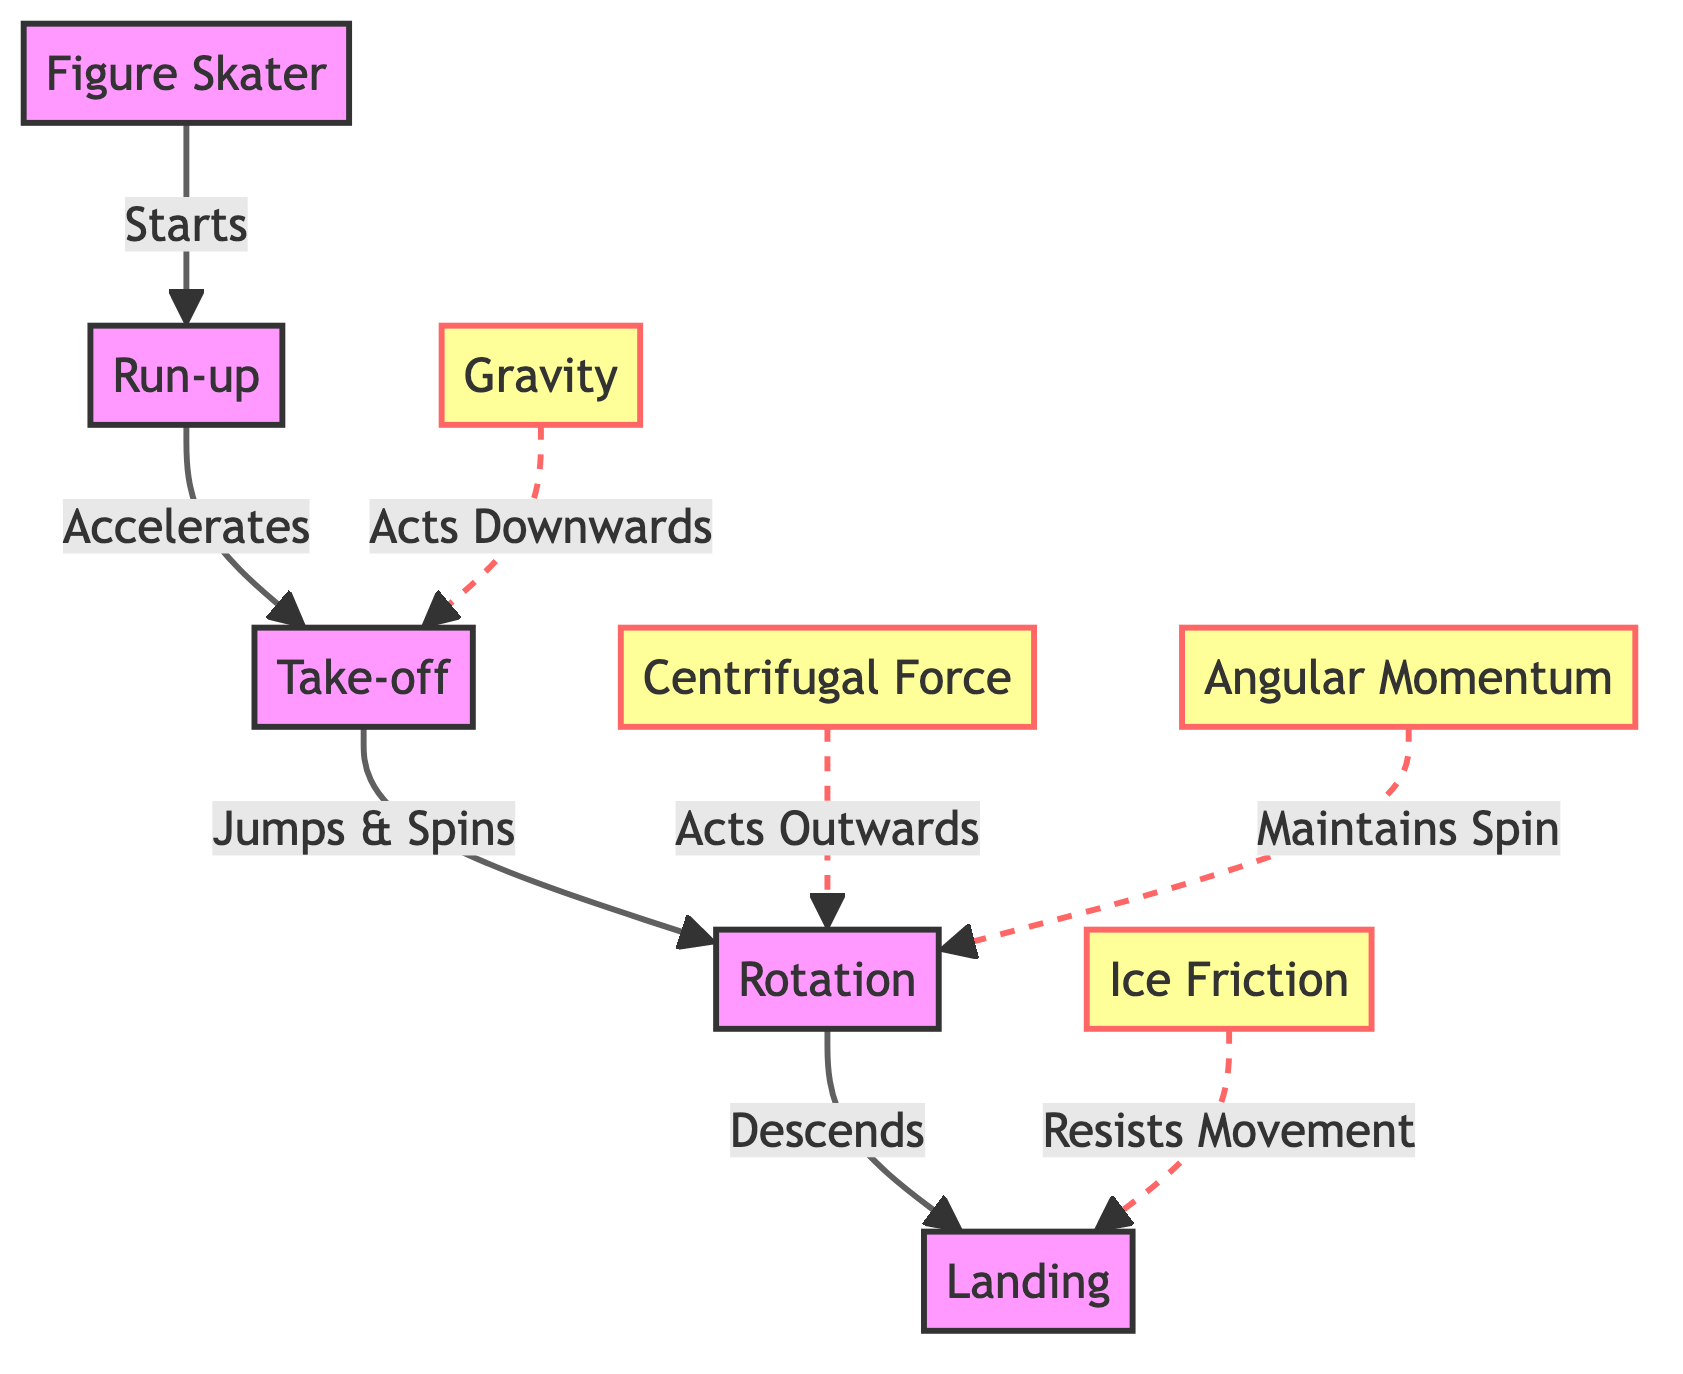What is the first step in the figure skater's jump? The diagram indicates that the skater starts with a run-up, which is the initial action before the jump.
Answer: Run-up Which force is depicted acting downwards during take-off? The diagram specifically lists gravity as acting downwards towards the take-off point, highlighting its influence at that stage.
Answer: Gravity What action occurs after the take-off stage? According to the flow of the diagram, the next action following take-off is the jump and spin, which takes place during the rotation phase.
Answer: Jumps & Spins What type of force acts outwards during the rotation? The diagram clearly identifies centrifugal force as the force acting outwardly while the skater is in the rotation phase.
Answer: Centrifugal Force How many nodes are in total in this diagram? By counting all the distinct entities in the diagram, including skater, run-up, take-off, rotation, and landing, we find there are five nodes in total.
Answer: Five What force acts to resist movement during landing? The diagram illustrates ice friction as the force that resists the skater's movement when landing on the ice, emphasizing its role in the sequence.
Answer: Ice Friction What maintains the spin during the rotation phase? The diagram denotes angular momentum as the sustaining factor for the skater's spin while rotating in the air, making it crucial for the jump.
Answer: Angular Momentum What happens immediately after the rotation phase? Following the rotation, the next action as indicated in the diagram is the descent towards landing, marking the transition in the jump's sequence.
Answer: Descends Which component does not directly affect the jump but is shown as a counteracting force? The ice friction, while not facilitating the jump, acts against the skater's momentum during landing, as represented in the diagram.
Answer: Ice Friction 